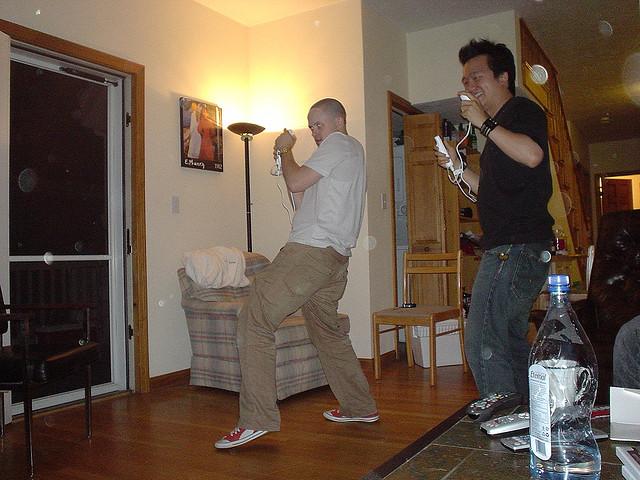How many remote controls are on the table?
Short answer required. 3. Is it day time outside?
Be succinct. No. Are they in a library?
Be succinct. No. Are they playing chess?
Concise answer only. No. 